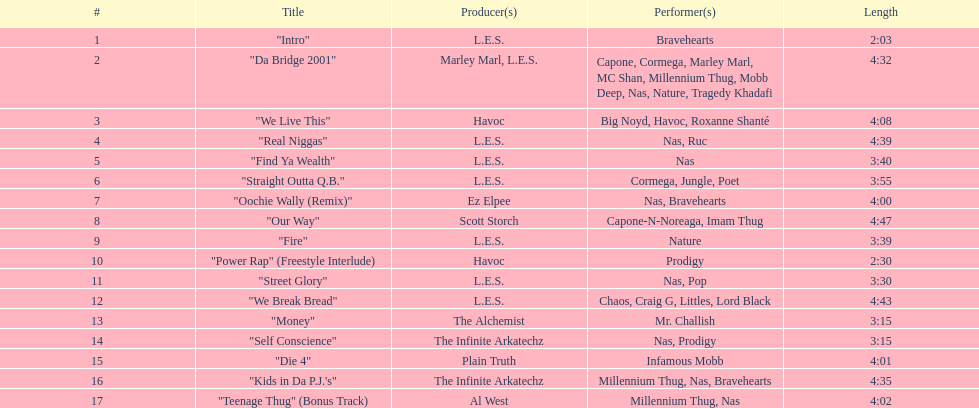How many tunes are no less than 4 minutes long? 9. 